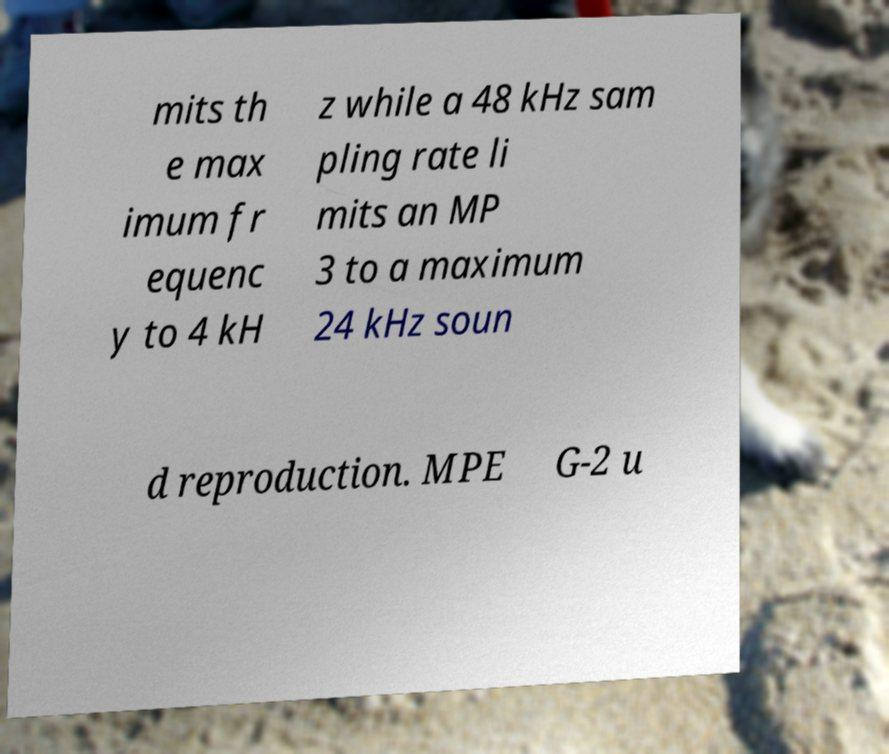Could you assist in decoding the text presented in this image and type it out clearly? mits th e max imum fr equenc y to 4 kH z while a 48 kHz sam pling rate li mits an MP 3 to a maximum 24 kHz soun d reproduction. MPE G-2 u 